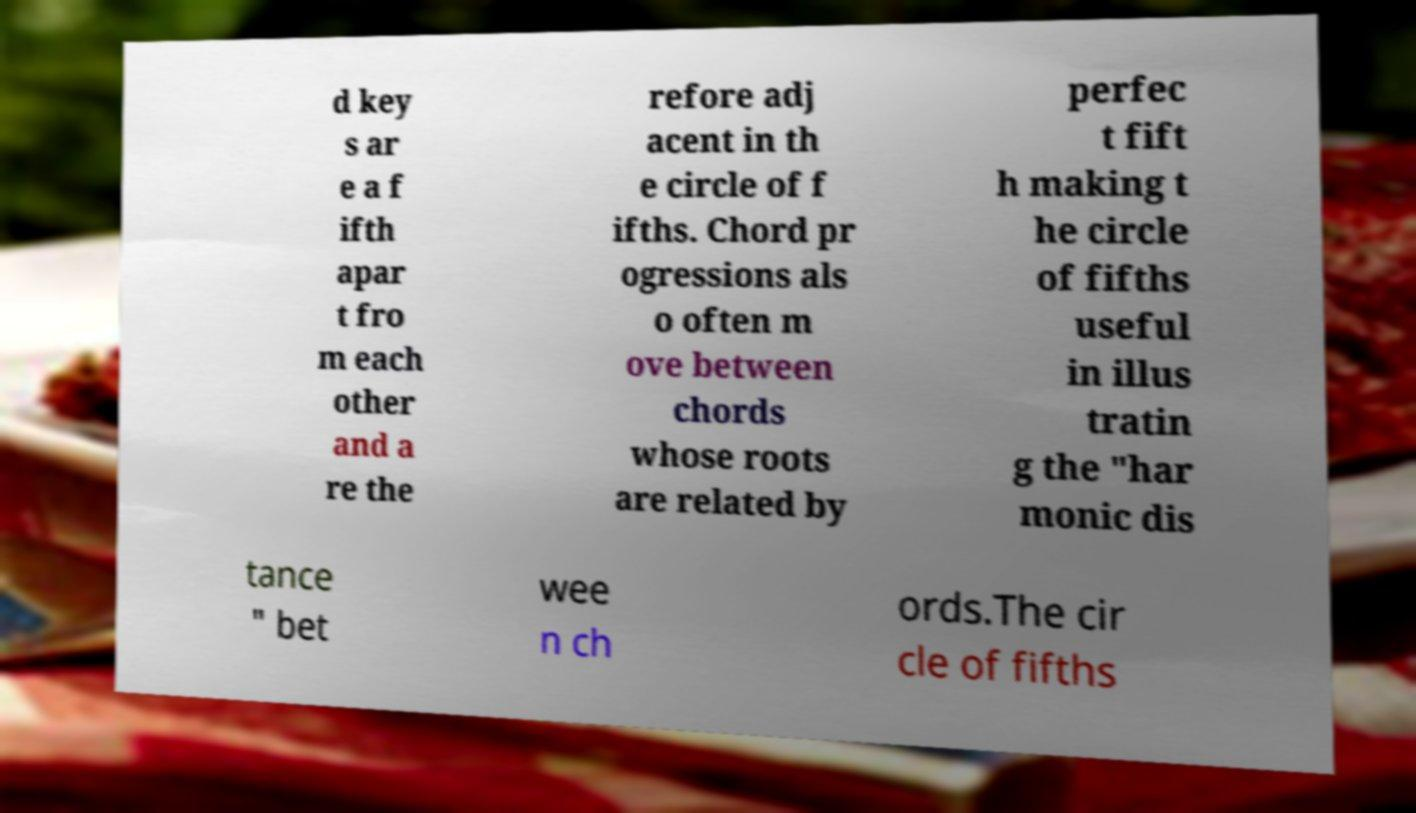Can you accurately transcribe the text from the provided image for me? d key s ar e a f ifth apar t fro m each other and a re the refore adj acent in th e circle of f ifths. Chord pr ogressions als o often m ove between chords whose roots are related by perfec t fift h making t he circle of fifths useful in illus tratin g the "har monic dis tance " bet wee n ch ords.The cir cle of fifths 